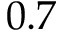<formula> <loc_0><loc_0><loc_500><loc_500>0 . 7</formula> 